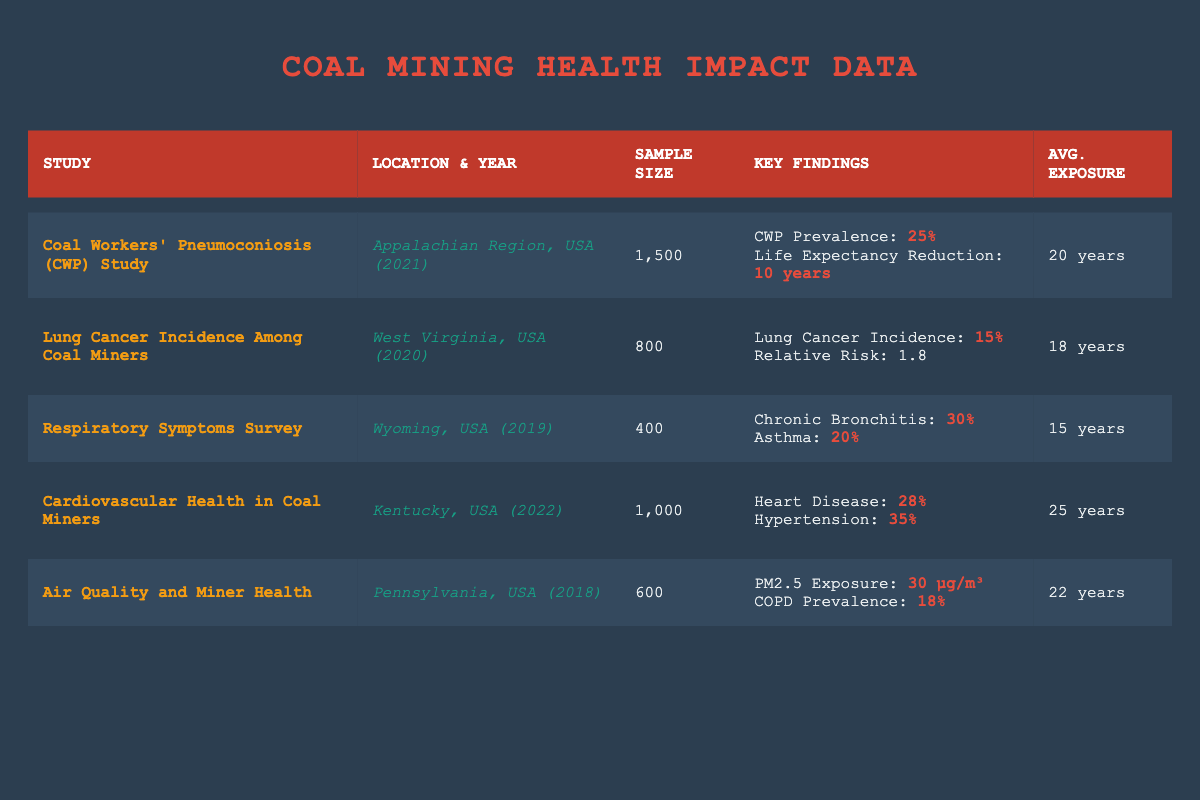What was the prevalence of Coal Workers' Pneumoconiosis according to the study in the Appalachian Region? The table indicates that the prevalence of Coal Workers' Pneumoconiosis (CWP) from the study in the Appalachian Region is specified as 25%.
Answer: 25% How many participants were surveyed in the Lung Cancer Incidence study? According to the table, the size of the sample surveyed in the Lung Cancer Incidence study was 800 participants.
Answer: 800 Between the studies on Cardiovascular Health and Respiratory Symptoms, which showed a higher average exposure to coal dust? The Cardiovascular Health in Coal Miners study shows an average exposure of 25 years, while the Respiratory Symptoms Survey shows an average exposure of 15 years. Therefore, the Cardiovascular Health study has a higher average exposure to coal dust.
Answer: Cardiovascular Health Is the Lung Cancer incidence among coal miners in West Virginia above or below 20%? The table presents the Lung Cancer Incidence as 15%, which is below 20%.
Answer: Below What is the combined prevalence of Chronic Bronchitis and Asthma found in the Respiratory Symptoms Survey? The prevalence of Chronic Bronchitis is 30% and Asthma is 20%. Adding these together gives 30% + 20% = 50%. Therefore, the combined prevalence is 50%.
Answer: 50% In which study was the life expectancy reduction reported, and what is the reported duration? The life expectancy reduction was reported in the Coal Workers' Pneumoconiosis (CWP) Study, and it states a reduction of 10 years.
Answer: 10 years Which location showed the highest prevalence of heart disease among coal miners? The table indicates that the highest prevalence of heart disease, at 28%, is found in the Kentucky study on Cardiovascular Health in Coal Miners, compared to other studies.
Answer: Kentucky How does the average exposure years compare between the study in Pennsylvania and the one in Wyoming? The average exposure years in Pennsylvania is 22 years while in Wyoming it is 15 years. When comparing the two, 22 years is higher than 15 years, indicating that miners in Pennsylvania had more exposure.
Answer: Pennsylvania What percentage of coal miners in the study from Kentucky reported hypertension? The table shows that 35% of coal miners in the Cardiovascular Health study from Kentucky reported hypertension.
Answer: 35% 